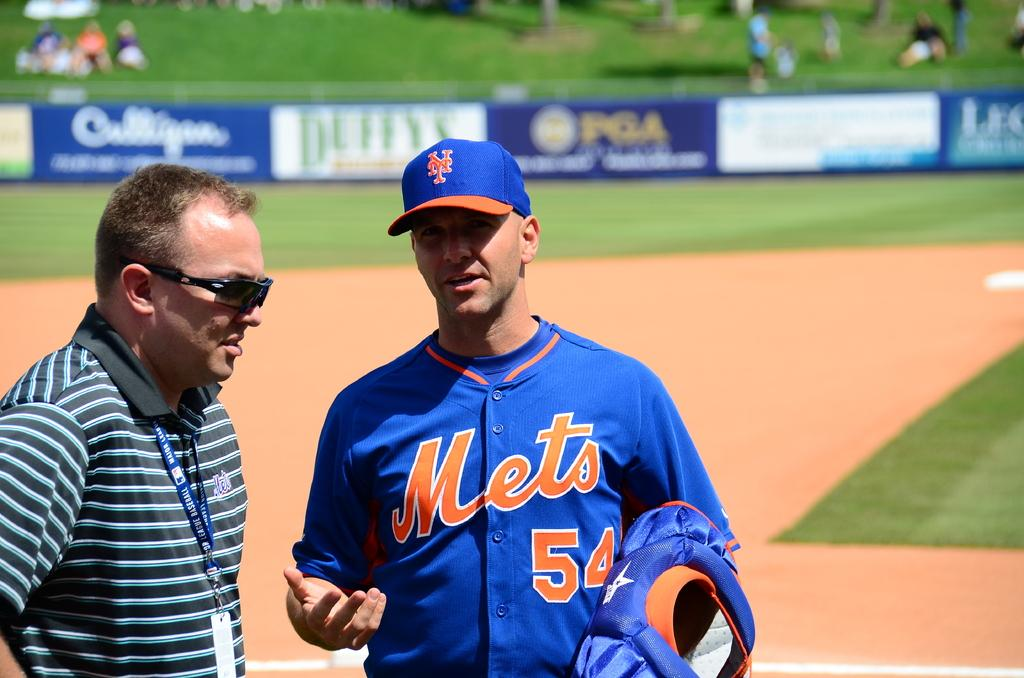<image>
Summarize the visual content of the image. a person that is wearing a blue Mets jersey 